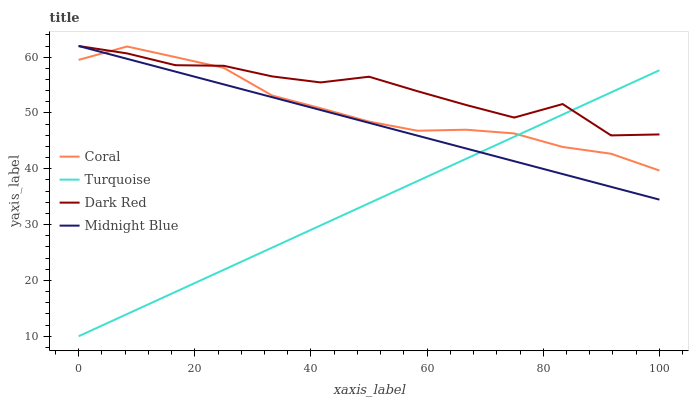Does Turquoise have the minimum area under the curve?
Answer yes or no. Yes. Does Dark Red have the maximum area under the curve?
Answer yes or no. Yes. Does Coral have the minimum area under the curve?
Answer yes or no. No. Does Coral have the maximum area under the curve?
Answer yes or no. No. Is Turquoise the smoothest?
Answer yes or no. Yes. Is Dark Red the roughest?
Answer yes or no. Yes. Is Coral the smoothest?
Answer yes or no. No. Is Coral the roughest?
Answer yes or no. No. Does Turquoise have the lowest value?
Answer yes or no. Yes. Does Coral have the lowest value?
Answer yes or no. No. Does Midnight Blue have the highest value?
Answer yes or no. Yes. Does Coral have the highest value?
Answer yes or no. No. Does Turquoise intersect Midnight Blue?
Answer yes or no. Yes. Is Turquoise less than Midnight Blue?
Answer yes or no. No. Is Turquoise greater than Midnight Blue?
Answer yes or no. No. 